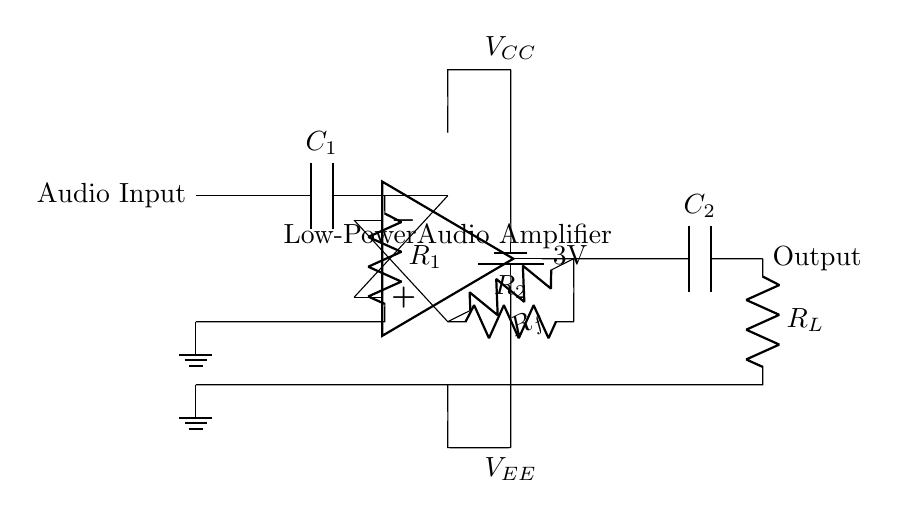What is the value of VCC in the circuit? The circuit shows a battery labeled as "3V," which is connected to the power supply of the amplifier. This indicates the positive voltage supply for the circuit.
Answer: 3V What component is used for audio input? The diagram features an "Audio Input" node, from which a signal is directly connected to a capacitor labeled C1, which is the first component for handling the audio signal.
Answer: Capacitor What type of amplifier is present in this circuit? The circuit contains an operational amplifier symbol indicating that it operates as an active device for amplification. This type of amplifier is commonly used in low-power applications for enhancing audio signals.
Answer: Operational amplifier What is the purpose of feedback in this circuit? The circuit shows a resistor labeled Rf connected from the output of the operational amplifier back to its inverting input. This feedback loop helps stabilize the amplifier gain and improve linearity by controlling the amplification level based on the output signal.
Answer: Stabilization What is the function of C2 in this circuit? C2 is connected in series with R_L at the output stage. Its primary role is to block direct current (DC) while allowing alternating current (AC) audio signals to pass through, ensuring that only the audio signal reaches the load (like a speaker) without DC offset.
Answer: Coupling capacitor How is the power supply polarized in this circuit? The circuit indicates that the battery has "3V" labeled for VCC and has a negative terminal going to ground, suggesting that it functions with a positive and a negative voltage supply, providing bipolar power to the operational amplifier.
Answer: Bipolar power supply 